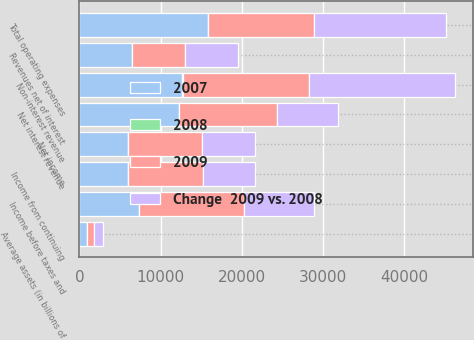<chart> <loc_0><loc_0><loc_500><loc_500><stacked_bar_chart><ecel><fcel>Net interest revenue<fcel>Non-interest revenue<fcel>Revenues net of interest<fcel>Total operating expenses<fcel>Income before taxes and<fcel>Income from continuing<fcel>Net income<fcel>Average assets (in billions of<nl><fcel>2009<fcel>12088<fcel>15558<fcel>6513<fcel>13053<fcel>12882<fcel>9152<fcel>9097<fcel>779<nl><fcel>2007<fcel>12255<fcel>12680<fcel>6513<fcel>15799<fcel>7296<fcel>5952<fcel>5965<fcel>966<nl><fcel>Change  2009 vs. 2008<fcel>7450<fcel>17906<fcel>6513<fcel>16178<fcel>8591<fcel>6513<fcel>6488<fcel>1085<nl><fcel>2008<fcel>1<fcel>23<fcel>11<fcel>17<fcel>77<fcel>54<fcel>53<fcel>19<nl></chart> 